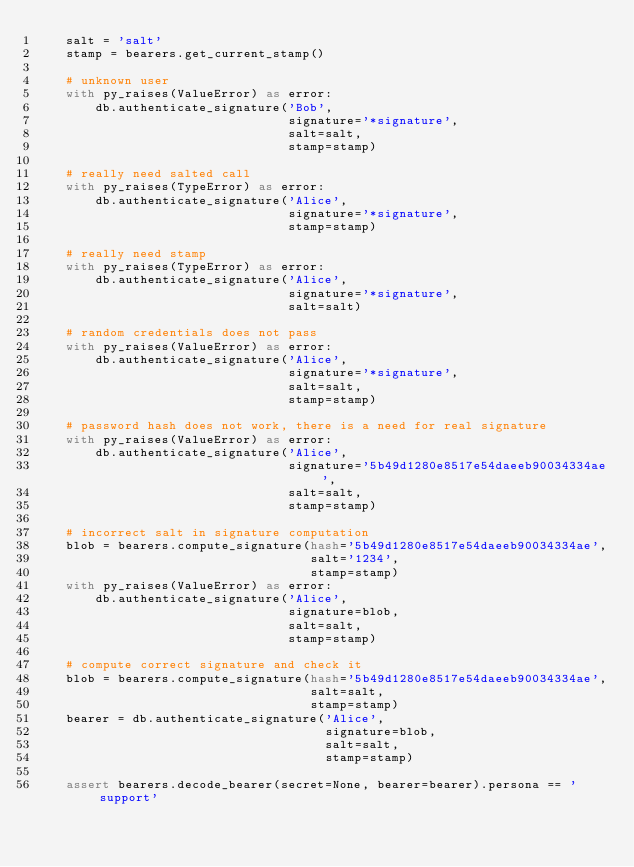Convert code to text. <code><loc_0><loc_0><loc_500><loc_500><_Python_>    salt = 'salt'
    stamp = bearers.get_current_stamp()

    # unknown user
    with py_raises(ValueError) as error:
        db.authenticate_signature('Bob',
                                  signature='*signature',
                                  salt=salt,
                                  stamp=stamp)

    # really need salted call
    with py_raises(TypeError) as error:
        db.authenticate_signature('Alice',
                                  signature='*signature',
                                  stamp=stamp)

    # really need stamp
    with py_raises(TypeError) as error:
        db.authenticate_signature('Alice',
                                  signature='*signature',
                                  salt=salt)

    # random credentials does not pass
    with py_raises(ValueError) as error:
        db.authenticate_signature('Alice',
                                  signature='*signature',
                                  salt=salt,
                                  stamp=stamp)

    # password hash does not work, there is a need for real signature
    with py_raises(ValueError) as error:
        db.authenticate_signature('Alice',
                                  signature='5b49d1280e8517e54daeeb90034334ae',
                                  salt=salt,
                                  stamp=stamp)

    # incorrect salt in signature computation
    blob = bearers.compute_signature(hash='5b49d1280e8517e54daeeb90034334ae',
                                     salt='1234',
                                     stamp=stamp)
    with py_raises(ValueError) as error:
        db.authenticate_signature('Alice',
                                  signature=blob,
                                  salt=salt,
                                  stamp=stamp)

    # compute correct signature and check it
    blob = bearers.compute_signature(hash='5b49d1280e8517e54daeeb90034334ae',
                                     salt=salt,
                                     stamp=stamp)
    bearer = db.authenticate_signature('Alice',
                                       signature=blob,
                                       salt=salt,
                                       stamp=stamp)

    assert bearers.decode_bearer(secret=None, bearer=bearer).persona == 'support'
</code> 